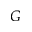<formula> <loc_0><loc_0><loc_500><loc_500>G</formula> 